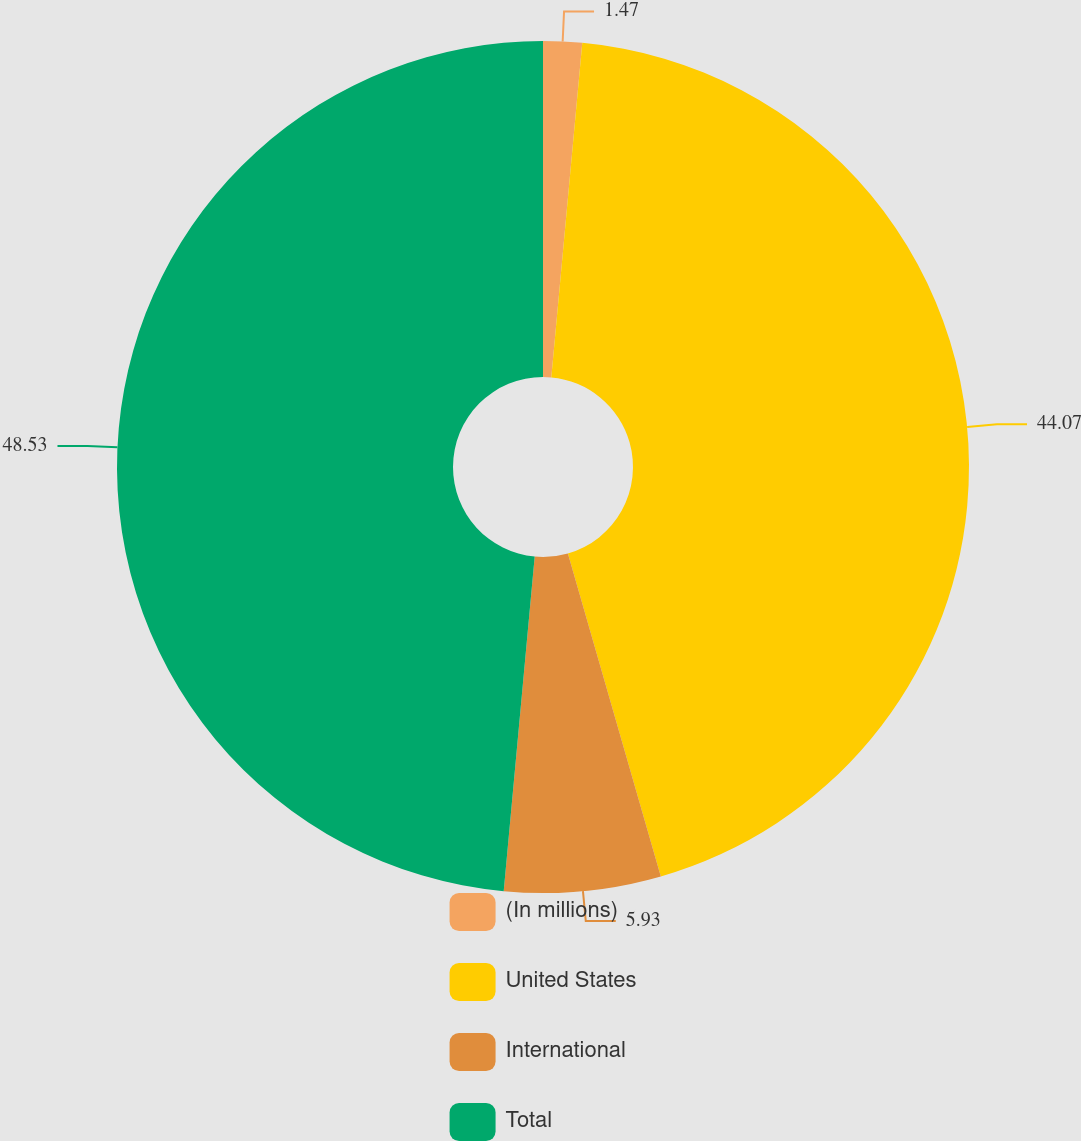<chart> <loc_0><loc_0><loc_500><loc_500><pie_chart><fcel>(In millions)<fcel>United States<fcel>International<fcel>Total<nl><fcel>1.47%<fcel>44.07%<fcel>5.93%<fcel>48.53%<nl></chart> 